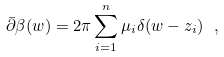Convert formula to latex. <formula><loc_0><loc_0><loc_500><loc_500>\bar { \partial } \beta ( w ) = 2 \pi \sum _ { i = 1 } ^ { n } \mu _ { i } \delta ( w - z _ { i } ) \ ,</formula> 